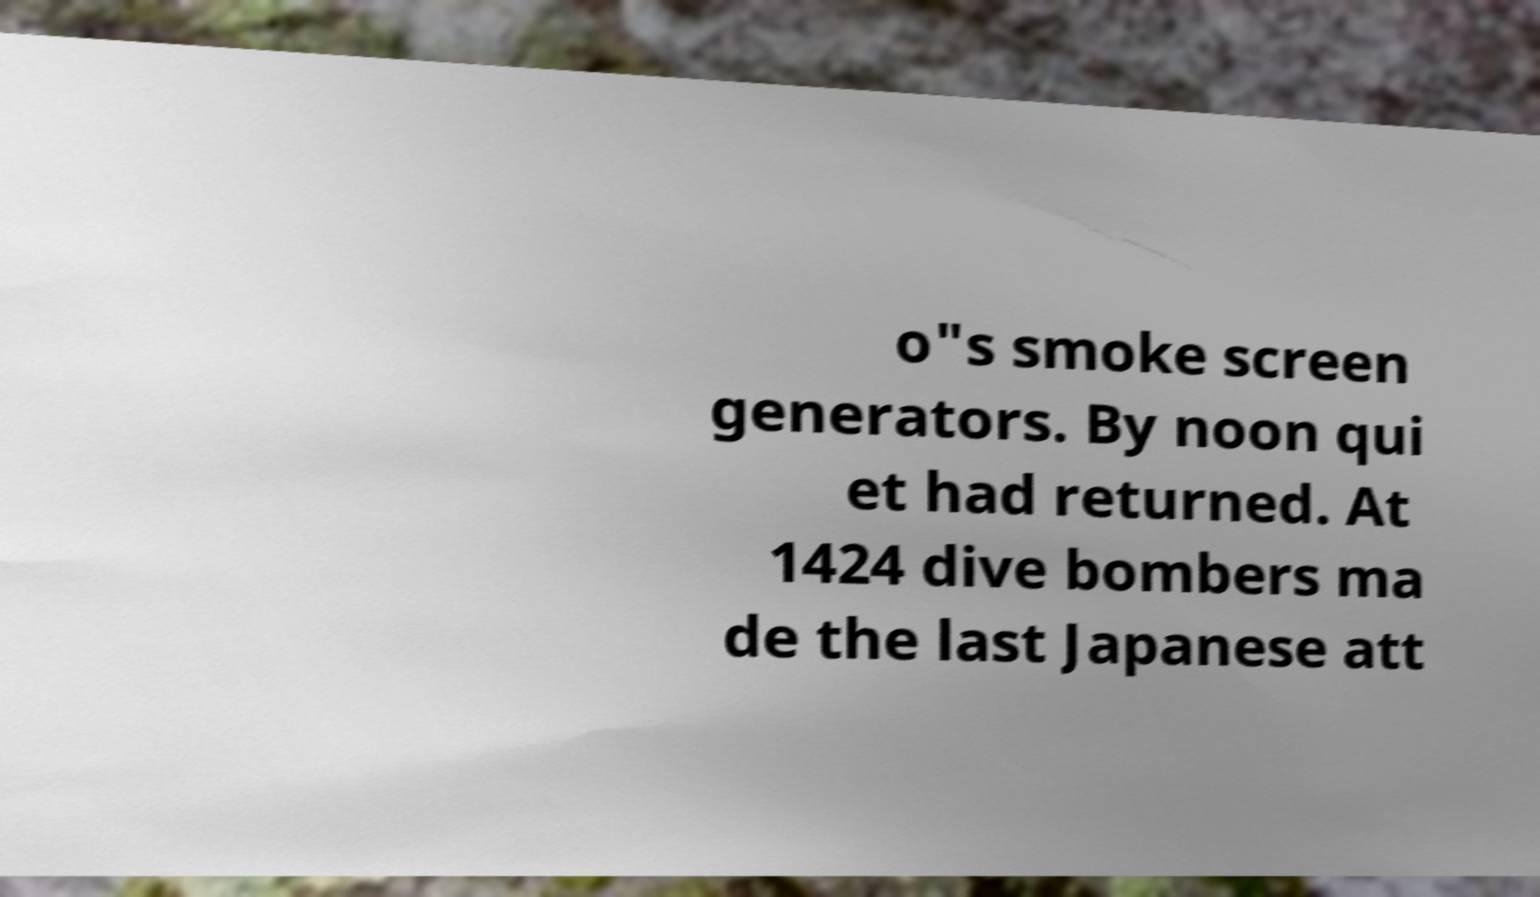Please identify and transcribe the text found in this image. o"s smoke screen generators. By noon qui et had returned. At 1424 dive bombers ma de the last Japanese att 